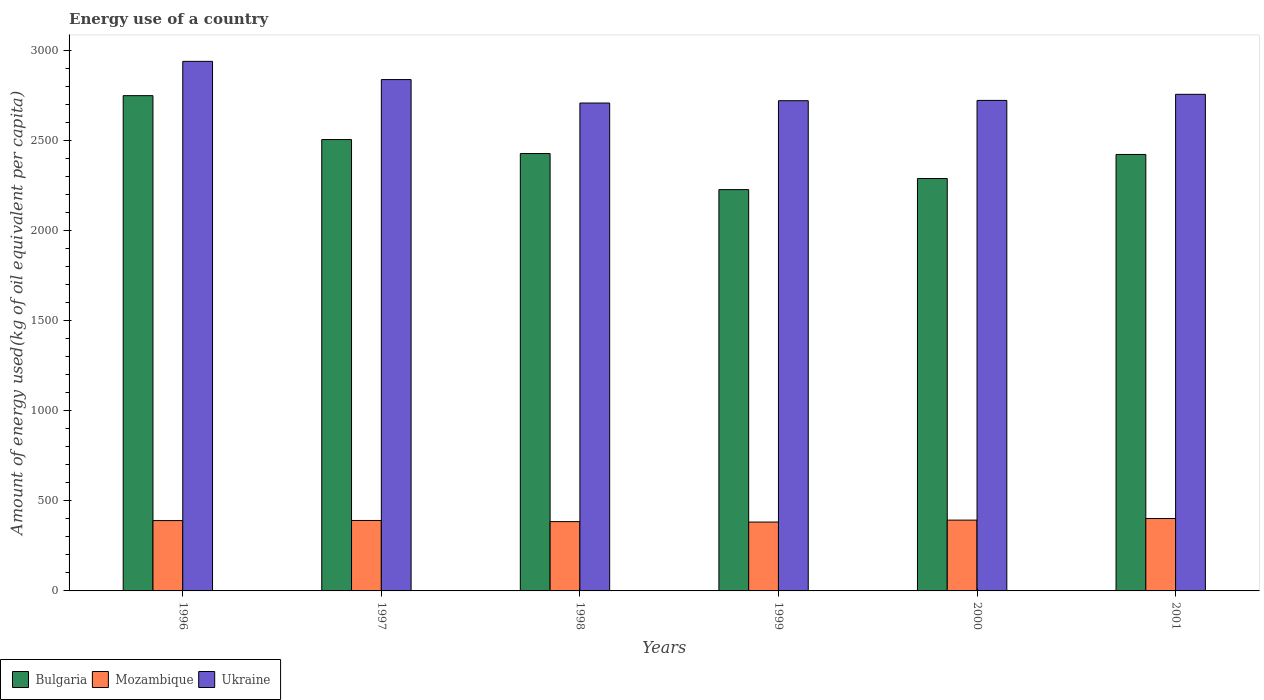How many different coloured bars are there?
Your answer should be compact. 3. How many groups of bars are there?
Offer a very short reply. 6. Are the number of bars per tick equal to the number of legend labels?
Provide a succinct answer. Yes. How many bars are there on the 6th tick from the left?
Keep it short and to the point. 3. What is the label of the 1st group of bars from the left?
Offer a terse response. 1996. In how many cases, is the number of bars for a given year not equal to the number of legend labels?
Offer a terse response. 0. What is the amount of energy used in in Bulgaria in 2000?
Keep it short and to the point. 2287.38. Across all years, what is the maximum amount of energy used in in Ukraine?
Offer a very short reply. 2937.27. Across all years, what is the minimum amount of energy used in in Mozambique?
Offer a terse response. 381.95. What is the total amount of energy used in in Ukraine in the graph?
Provide a short and direct response. 1.67e+04. What is the difference between the amount of energy used in in Ukraine in 1997 and that in 1999?
Your answer should be compact. 117.22. What is the difference between the amount of energy used in in Ukraine in 2001 and the amount of energy used in in Bulgaria in 1999?
Keep it short and to the point. 528.55. What is the average amount of energy used in in Bulgaria per year?
Keep it short and to the point. 2435.09. In the year 2001, what is the difference between the amount of energy used in in Bulgaria and amount of energy used in in Mozambique?
Your answer should be compact. 2019.27. What is the ratio of the amount of energy used in in Ukraine in 1997 to that in 1999?
Your answer should be very brief. 1.04. What is the difference between the highest and the second highest amount of energy used in in Bulgaria?
Make the answer very short. 243.43. What is the difference between the highest and the lowest amount of energy used in in Bulgaria?
Offer a very short reply. 521.09. What does the 2nd bar from the left in 2000 represents?
Ensure brevity in your answer.  Mozambique. What does the 3rd bar from the right in 1997 represents?
Offer a terse response. Bulgaria. Is it the case that in every year, the sum of the amount of energy used in in Mozambique and amount of energy used in in Bulgaria is greater than the amount of energy used in in Ukraine?
Your answer should be compact. No. How many bars are there?
Provide a short and direct response. 18. How many years are there in the graph?
Keep it short and to the point. 6. What is the difference between two consecutive major ticks on the Y-axis?
Offer a very short reply. 500. Are the values on the major ticks of Y-axis written in scientific E-notation?
Keep it short and to the point. No. Does the graph contain grids?
Your answer should be very brief. No. Where does the legend appear in the graph?
Your answer should be very brief. Bottom left. How many legend labels are there?
Provide a succinct answer. 3. How are the legend labels stacked?
Offer a very short reply. Horizontal. What is the title of the graph?
Your answer should be compact. Energy use of a country. Does "Libya" appear as one of the legend labels in the graph?
Provide a succinct answer. No. What is the label or title of the Y-axis?
Keep it short and to the point. Amount of energy used(kg of oil equivalent per capita). What is the Amount of energy used(kg of oil equivalent per capita) in Bulgaria in 1996?
Give a very brief answer. 2746.96. What is the Amount of energy used(kg of oil equivalent per capita) in Mozambique in 1996?
Make the answer very short. 390.08. What is the Amount of energy used(kg of oil equivalent per capita) in Ukraine in 1996?
Keep it short and to the point. 2937.27. What is the Amount of energy used(kg of oil equivalent per capita) in Bulgaria in 1997?
Make the answer very short. 2503.53. What is the Amount of energy used(kg of oil equivalent per capita) in Mozambique in 1997?
Provide a succinct answer. 390.69. What is the Amount of energy used(kg of oil equivalent per capita) of Ukraine in 1997?
Provide a succinct answer. 2836.21. What is the Amount of energy used(kg of oil equivalent per capita) in Bulgaria in 1998?
Give a very brief answer. 2425.95. What is the Amount of energy used(kg of oil equivalent per capita) of Mozambique in 1998?
Give a very brief answer. 384.44. What is the Amount of energy used(kg of oil equivalent per capita) of Ukraine in 1998?
Ensure brevity in your answer.  2706.14. What is the Amount of energy used(kg of oil equivalent per capita) in Bulgaria in 1999?
Give a very brief answer. 2225.87. What is the Amount of energy used(kg of oil equivalent per capita) of Mozambique in 1999?
Your answer should be compact. 381.95. What is the Amount of energy used(kg of oil equivalent per capita) of Ukraine in 1999?
Provide a succinct answer. 2718.99. What is the Amount of energy used(kg of oil equivalent per capita) in Bulgaria in 2000?
Offer a very short reply. 2287.38. What is the Amount of energy used(kg of oil equivalent per capita) in Mozambique in 2000?
Your answer should be compact. 392.71. What is the Amount of energy used(kg of oil equivalent per capita) of Ukraine in 2000?
Ensure brevity in your answer.  2720.72. What is the Amount of energy used(kg of oil equivalent per capita) in Bulgaria in 2001?
Provide a succinct answer. 2420.85. What is the Amount of energy used(kg of oil equivalent per capita) of Mozambique in 2001?
Keep it short and to the point. 401.58. What is the Amount of energy used(kg of oil equivalent per capita) of Ukraine in 2001?
Offer a very short reply. 2754.42. Across all years, what is the maximum Amount of energy used(kg of oil equivalent per capita) in Bulgaria?
Provide a short and direct response. 2746.96. Across all years, what is the maximum Amount of energy used(kg of oil equivalent per capita) of Mozambique?
Your response must be concise. 401.58. Across all years, what is the maximum Amount of energy used(kg of oil equivalent per capita) of Ukraine?
Offer a very short reply. 2937.27. Across all years, what is the minimum Amount of energy used(kg of oil equivalent per capita) in Bulgaria?
Offer a very short reply. 2225.87. Across all years, what is the minimum Amount of energy used(kg of oil equivalent per capita) in Mozambique?
Provide a short and direct response. 381.95. Across all years, what is the minimum Amount of energy used(kg of oil equivalent per capita) of Ukraine?
Give a very brief answer. 2706.14. What is the total Amount of energy used(kg of oil equivalent per capita) of Bulgaria in the graph?
Ensure brevity in your answer.  1.46e+04. What is the total Amount of energy used(kg of oil equivalent per capita) in Mozambique in the graph?
Your response must be concise. 2341.44. What is the total Amount of energy used(kg of oil equivalent per capita) in Ukraine in the graph?
Offer a terse response. 1.67e+04. What is the difference between the Amount of energy used(kg of oil equivalent per capita) in Bulgaria in 1996 and that in 1997?
Offer a very short reply. 243.43. What is the difference between the Amount of energy used(kg of oil equivalent per capita) of Mozambique in 1996 and that in 1997?
Provide a succinct answer. -0.6. What is the difference between the Amount of energy used(kg of oil equivalent per capita) in Ukraine in 1996 and that in 1997?
Your answer should be very brief. 101.06. What is the difference between the Amount of energy used(kg of oil equivalent per capita) of Bulgaria in 1996 and that in 1998?
Offer a very short reply. 321.01. What is the difference between the Amount of energy used(kg of oil equivalent per capita) of Mozambique in 1996 and that in 1998?
Make the answer very short. 5.64. What is the difference between the Amount of energy used(kg of oil equivalent per capita) of Ukraine in 1996 and that in 1998?
Offer a very short reply. 231.14. What is the difference between the Amount of energy used(kg of oil equivalent per capita) of Bulgaria in 1996 and that in 1999?
Provide a short and direct response. 521.09. What is the difference between the Amount of energy used(kg of oil equivalent per capita) in Mozambique in 1996 and that in 1999?
Your answer should be very brief. 8.14. What is the difference between the Amount of energy used(kg of oil equivalent per capita) in Ukraine in 1996 and that in 1999?
Give a very brief answer. 218.28. What is the difference between the Amount of energy used(kg of oil equivalent per capita) of Bulgaria in 1996 and that in 2000?
Your answer should be compact. 459.58. What is the difference between the Amount of energy used(kg of oil equivalent per capita) in Mozambique in 1996 and that in 2000?
Provide a short and direct response. -2.63. What is the difference between the Amount of energy used(kg of oil equivalent per capita) of Ukraine in 1996 and that in 2000?
Your answer should be compact. 216.55. What is the difference between the Amount of energy used(kg of oil equivalent per capita) in Bulgaria in 1996 and that in 2001?
Provide a succinct answer. 326.11. What is the difference between the Amount of energy used(kg of oil equivalent per capita) of Mozambique in 1996 and that in 2001?
Your response must be concise. -11.5. What is the difference between the Amount of energy used(kg of oil equivalent per capita) in Ukraine in 1996 and that in 2001?
Your answer should be compact. 182.85. What is the difference between the Amount of energy used(kg of oil equivalent per capita) of Bulgaria in 1997 and that in 1998?
Provide a short and direct response. 77.58. What is the difference between the Amount of energy used(kg of oil equivalent per capita) of Mozambique in 1997 and that in 1998?
Provide a short and direct response. 6.25. What is the difference between the Amount of energy used(kg of oil equivalent per capita) in Ukraine in 1997 and that in 1998?
Your answer should be very brief. 130.07. What is the difference between the Amount of energy used(kg of oil equivalent per capita) in Bulgaria in 1997 and that in 1999?
Offer a very short reply. 277.65. What is the difference between the Amount of energy used(kg of oil equivalent per capita) in Mozambique in 1997 and that in 1999?
Your answer should be compact. 8.74. What is the difference between the Amount of energy used(kg of oil equivalent per capita) in Ukraine in 1997 and that in 1999?
Offer a terse response. 117.22. What is the difference between the Amount of energy used(kg of oil equivalent per capita) of Bulgaria in 1997 and that in 2000?
Provide a short and direct response. 216.14. What is the difference between the Amount of energy used(kg of oil equivalent per capita) of Mozambique in 1997 and that in 2000?
Your answer should be compact. -2.03. What is the difference between the Amount of energy used(kg of oil equivalent per capita) in Ukraine in 1997 and that in 2000?
Provide a succinct answer. 115.48. What is the difference between the Amount of energy used(kg of oil equivalent per capita) in Bulgaria in 1997 and that in 2001?
Make the answer very short. 82.67. What is the difference between the Amount of energy used(kg of oil equivalent per capita) in Mozambique in 1997 and that in 2001?
Give a very brief answer. -10.9. What is the difference between the Amount of energy used(kg of oil equivalent per capita) in Ukraine in 1997 and that in 2001?
Your response must be concise. 81.78. What is the difference between the Amount of energy used(kg of oil equivalent per capita) of Bulgaria in 1998 and that in 1999?
Your response must be concise. 200.07. What is the difference between the Amount of energy used(kg of oil equivalent per capita) of Mozambique in 1998 and that in 1999?
Keep it short and to the point. 2.49. What is the difference between the Amount of energy used(kg of oil equivalent per capita) in Ukraine in 1998 and that in 1999?
Ensure brevity in your answer.  -12.86. What is the difference between the Amount of energy used(kg of oil equivalent per capita) in Bulgaria in 1998 and that in 2000?
Your response must be concise. 138.56. What is the difference between the Amount of energy used(kg of oil equivalent per capita) in Mozambique in 1998 and that in 2000?
Your response must be concise. -8.27. What is the difference between the Amount of energy used(kg of oil equivalent per capita) of Ukraine in 1998 and that in 2000?
Provide a short and direct response. -14.59. What is the difference between the Amount of energy used(kg of oil equivalent per capita) of Bulgaria in 1998 and that in 2001?
Provide a succinct answer. 5.09. What is the difference between the Amount of energy used(kg of oil equivalent per capita) of Mozambique in 1998 and that in 2001?
Ensure brevity in your answer.  -17.14. What is the difference between the Amount of energy used(kg of oil equivalent per capita) in Ukraine in 1998 and that in 2001?
Provide a succinct answer. -48.29. What is the difference between the Amount of energy used(kg of oil equivalent per capita) of Bulgaria in 1999 and that in 2000?
Ensure brevity in your answer.  -61.51. What is the difference between the Amount of energy used(kg of oil equivalent per capita) in Mozambique in 1999 and that in 2000?
Offer a very short reply. -10.76. What is the difference between the Amount of energy used(kg of oil equivalent per capita) of Ukraine in 1999 and that in 2000?
Your response must be concise. -1.73. What is the difference between the Amount of energy used(kg of oil equivalent per capita) of Bulgaria in 1999 and that in 2001?
Your response must be concise. -194.98. What is the difference between the Amount of energy used(kg of oil equivalent per capita) in Mozambique in 1999 and that in 2001?
Provide a succinct answer. -19.63. What is the difference between the Amount of energy used(kg of oil equivalent per capita) in Ukraine in 1999 and that in 2001?
Your answer should be very brief. -35.43. What is the difference between the Amount of energy used(kg of oil equivalent per capita) in Bulgaria in 2000 and that in 2001?
Provide a short and direct response. -133.47. What is the difference between the Amount of energy used(kg of oil equivalent per capita) of Mozambique in 2000 and that in 2001?
Keep it short and to the point. -8.87. What is the difference between the Amount of energy used(kg of oil equivalent per capita) of Ukraine in 2000 and that in 2001?
Ensure brevity in your answer.  -33.7. What is the difference between the Amount of energy used(kg of oil equivalent per capita) in Bulgaria in 1996 and the Amount of energy used(kg of oil equivalent per capita) in Mozambique in 1997?
Make the answer very short. 2356.28. What is the difference between the Amount of energy used(kg of oil equivalent per capita) in Bulgaria in 1996 and the Amount of energy used(kg of oil equivalent per capita) in Ukraine in 1997?
Keep it short and to the point. -89.25. What is the difference between the Amount of energy used(kg of oil equivalent per capita) of Mozambique in 1996 and the Amount of energy used(kg of oil equivalent per capita) of Ukraine in 1997?
Provide a succinct answer. -2446.13. What is the difference between the Amount of energy used(kg of oil equivalent per capita) in Bulgaria in 1996 and the Amount of energy used(kg of oil equivalent per capita) in Mozambique in 1998?
Your answer should be very brief. 2362.52. What is the difference between the Amount of energy used(kg of oil equivalent per capita) in Bulgaria in 1996 and the Amount of energy used(kg of oil equivalent per capita) in Ukraine in 1998?
Offer a very short reply. 40.82. What is the difference between the Amount of energy used(kg of oil equivalent per capita) of Mozambique in 1996 and the Amount of energy used(kg of oil equivalent per capita) of Ukraine in 1998?
Keep it short and to the point. -2316.05. What is the difference between the Amount of energy used(kg of oil equivalent per capita) in Bulgaria in 1996 and the Amount of energy used(kg of oil equivalent per capita) in Mozambique in 1999?
Offer a terse response. 2365.01. What is the difference between the Amount of energy used(kg of oil equivalent per capita) in Bulgaria in 1996 and the Amount of energy used(kg of oil equivalent per capita) in Ukraine in 1999?
Make the answer very short. 27.97. What is the difference between the Amount of energy used(kg of oil equivalent per capita) of Mozambique in 1996 and the Amount of energy used(kg of oil equivalent per capita) of Ukraine in 1999?
Make the answer very short. -2328.91. What is the difference between the Amount of energy used(kg of oil equivalent per capita) in Bulgaria in 1996 and the Amount of energy used(kg of oil equivalent per capita) in Mozambique in 2000?
Offer a terse response. 2354.25. What is the difference between the Amount of energy used(kg of oil equivalent per capita) of Bulgaria in 1996 and the Amount of energy used(kg of oil equivalent per capita) of Ukraine in 2000?
Provide a succinct answer. 26.24. What is the difference between the Amount of energy used(kg of oil equivalent per capita) of Mozambique in 1996 and the Amount of energy used(kg of oil equivalent per capita) of Ukraine in 2000?
Offer a very short reply. -2330.64. What is the difference between the Amount of energy used(kg of oil equivalent per capita) in Bulgaria in 1996 and the Amount of energy used(kg of oil equivalent per capita) in Mozambique in 2001?
Your response must be concise. 2345.38. What is the difference between the Amount of energy used(kg of oil equivalent per capita) of Bulgaria in 1996 and the Amount of energy used(kg of oil equivalent per capita) of Ukraine in 2001?
Offer a very short reply. -7.46. What is the difference between the Amount of energy used(kg of oil equivalent per capita) of Mozambique in 1996 and the Amount of energy used(kg of oil equivalent per capita) of Ukraine in 2001?
Keep it short and to the point. -2364.34. What is the difference between the Amount of energy used(kg of oil equivalent per capita) of Bulgaria in 1997 and the Amount of energy used(kg of oil equivalent per capita) of Mozambique in 1998?
Offer a terse response. 2119.09. What is the difference between the Amount of energy used(kg of oil equivalent per capita) in Bulgaria in 1997 and the Amount of energy used(kg of oil equivalent per capita) in Ukraine in 1998?
Provide a short and direct response. -202.61. What is the difference between the Amount of energy used(kg of oil equivalent per capita) in Mozambique in 1997 and the Amount of energy used(kg of oil equivalent per capita) in Ukraine in 1998?
Make the answer very short. -2315.45. What is the difference between the Amount of energy used(kg of oil equivalent per capita) of Bulgaria in 1997 and the Amount of energy used(kg of oil equivalent per capita) of Mozambique in 1999?
Your answer should be very brief. 2121.58. What is the difference between the Amount of energy used(kg of oil equivalent per capita) in Bulgaria in 1997 and the Amount of energy used(kg of oil equivalent per capita) in Ukraine in 1999?
Make the answer very short. -215.47. What is the difference between the Amount of energy used(kg of oil equivalent per capita) of Mozambique in 1997 and the Amount of energy used(kg of oil equivalent per capita) of Ukraine in 1999?
Provide a short and direct response. -2328.31. What is the difference between the Amount of energy used(kg of oil equivalent per capita) in Bulgaria in 1997 and the Amount of energy used(kg of oil equivalent per capita) in Mozambique in 2000?
Keep it short and to the point. 2110.82. What is the difference between the Amount of energy used(kg of oil equivalent per capita) of Bulgaria in 1997 and the Amount of energy used(kg of oil equivalent per capita) of Ukraine in 2000?
Give a very brief answer. -217.2. What is the difference between the Amount of energy used(kg of oil equivalent per capita) of Mozambique in 1997 and the Amount of energy used(kg of oil equivalent per capita) of Ukraine in 2000?
Offer a terse response. -2330.04. What is the difference between the Amount of energy used(kg of oil equivalent per capita) in Bulgaria in 1997 and the Amount of energy used(kg of oil equivalent per capita) in Mozambique in 2001?
Give a very brief answer. 2101.94. What is the difference between the Amount of energy used(kg of oil equivalent per capita) in Bulgaria in 1997 and the Amount of energy used(kg of oil equivalent per capita) in Ukraine in 2001?
Offer a terse response. -250.9. What is the difference between the Amount of energy used(kg of oil equivalent per capita) of Mozambique in 1997 and the Amount of energy used(kg of oil equivalent per capita) of Ukraine in 2001?
Offer a terse response. -2363.74. What is the difference between the Amount of energy used(kg of oil equivalent per capita) of Bulgaria in 1998 and the Amount of energy used(kg of oil equivalent per capita) of Mozambique in 1999?
Provide a succinct answer. 2044. What is the difference between the Amount of energy used(kg of oil equivalent per capita) in Bulgaria in 1998 and the Amount of energy used(kg of oil equivalent per capita) in Ukraine in 1999?
Provide a succinct answer. -293.05. What is the difference between the Amount of energy used(kg of oil equivalent per capita) of Mozambique in 1998 and the Amount of energy used(kg of oil equivalent per capita) of Ukraine in 1999?
Give a very brief answer. -2334.55. What is the difference between the Amount of energy used(kg of oil equivalent per capita) in Bulgaria in 1998 and the Amount of energy used(kg of oil equivalent per capita) in Mozambique in 2000?
Offer a very short reply. 2033.24. What is the difference between the Amount of energy used(kg of oil equivalent per capita) of Bulgaria in 1998 and the Amount of energy used(kg of oil equivalent per capita) of Ukraine in 2000?
Your answer should be compact. -294.78. What is the difference between the Amount of energy used(kg of oil equivalent per capita) of Mozambique in 1998 and the Amount of energy used(kg of oil equivalent per capita) of Ukraine in 2000?
Make the answer very short. -2336.29. What is the difference between the Amount of energy used(kg of oil equivalent per capita) in Bulgaria in 1998 and the Amount of energy used(kg of oil equivalent per capita) in Mozambique in 2001?
Give a very brief answer. 2024.36. What is the difference between the Amount of energy used(kg of oil equivalent per capita) of Bulgaria in 1998 and the Amount of energy used(kg of oil equivalent per capita) of Ukraine in 2001?
Provide a succinct answer. -328.48. What is the difference between the Amount of energy used(kg of oil equivalent per capita) in Mozambique in 1998 and the Amount of energy used(kg of oil equivalent per capita) in Ukraine in 2001?
Your answer should be compact. -2369.99. What is the difference between the Amount of energy used(kg of oil equivalent per capita) in Bulgaria in 1999 and the Amount of energy used(kg of oil equivalent per capita) in Mozambique in 2000?
Offer a very short reply. 1833.16. What is the difference between the Amount of energy used(kg of oil equivalent per capita) of Bulgaria in 1999 and the Amount of energy used(kg of oil equivalent per capita) of Ukraine in 2000?
Offer a very short reply. -494.85. What is the difference between the Amount of energy used(kg of oil equivalent per capita) of Mozambique in 1999 and the Amount of energy used(kg of oil equivalent per capita) of Ukraine in 2000?
Offer a terse response. -2338.78. What is the difference between the Amount of energy used(kg of oil equivalent per capita) of Bulgaria in 1999 and the Amount of energy used(kg of oil equivalent per capita) of Mozambique in 2001?
Ensure brevity in your answer.  1824.29. What is the difference between the Amount of energy used(kg of oil equivalent per capita) of Bulgaria in 1999 and the Amount of energy used(kg of oil equivalent per capita) of Ukraine in 2001?
Ensure brevity in your answer.  -528.55. What is the difference between the Amount of energy used(kg of oil equivalent per capita) in Mozambique in 1999 and the Amount of energy used(kg of oil equivalent per capita) in Ukraine in 2001?
Keep it short and to the point. -2372.48. What is the difference between the Amount of energy used(kg of oil equivalent per capita) of Bulgaria in 2000 and the Amount of energy used(kg of oil equivalent per capita) of Mozambique in 2001?
Give a very brief answer. 1885.8. What is the difference between the Amount of energy used(kg of oil equivalent per capita) of Bulgaria in 2000 and the Amount of energy used(kg of oil equivalent per capita) of Ukraine in 2001?
Your answer should be compact. -467.04. What is the difference between the Amount of energy used(kg of oil equivalent per capita) of Mozambique in 2000 and the Amount of energy used(kg of oil equivalent per capita) of Ukraine in 2001?
Your answer should be very brief. -2361.71. What is the average Amount of energy used(kg of oil equivalent per capita) of Bulgaria per year?
Offer a terse response. 2435.09. What is the average Amount of energy used(kg of oil equivalent per capita) of Mozambique per year?
Provide a short and direct response. 390.24. What is the average Amount of energy used(kg of oil equivalent per capita) in Ukraine per year?
Give a very brief answer. 2778.96. In the year 1996, what is the difference between the Amount of energy used(kg of oil equivalent per capita) in Bulgaria and Amount of energy used(kg of oil equivalent per capita) in Mozambique?
Keep it short and to the point. 2356.88. In the year 1996, what is the difference between the Amount of energy used(kg of oil equivalent per capita) of Bulgaria and Amount of energy used(kg of oil equivalent per capita) of Ukraine?
Give a very brief answer. -190.31. In the year 1996, what is the difference between the Amount of energy used(kg of oil equivalent per capita) of Mozambique and Amount of energy used(kg of oil equivalent per capita) of Ukraine?
Your response must be concise. -2547.19. In the year 1997, what is the difference between the Amount of energy used(kg of oil equivalent per capita) in Bulgaria and Amount of energy used(kg of oil equivalent per capita) in Mozambique?
Provide a succinct answer. 2112.84. In the year 1997, what is the difference between the Amount of energy used(kg of oil equivalent per capita) in Bulgaria and Amount of energy used(kg of oil equivalent per capita) in Ukraine?
Give a very brief answer. -332.68. In the year 1997, what is the difference between the Amount of energy used(kg of oil equivalent per capita) of Mozambique and Amount of energy used(kg of oil equivalent per capita) of Ukraine?
Ensure brevity in your answer.  -2445.52. In the year 1998, what is the difference between the Amount of energy used(kg of oil equivalent per capita) of Bulgaria and Amount of energy used(kg of oil equivalent per capita) of Mozambique?
Offer a terse response. 2041.51. In the year 1998, what is the difference between the Amount of energy used(kg of oil equivalent per capita) in Bulgaria and Amount of energy used(kg of oil equivalent per capita) in Ukraine?
Offer a very short reply. -280.19. In the year 1998, what is the difference between the Amount of energy used(kg of oil equivalent per capita) in Mozambique and Amount of energy used(kg of oil equivalent per capita) in Ukraine?
Keep it short and to the point. -2321.7. In the year 1999, what is the difference between the Amount of energy used(kg of oil equivalent per capita) of Bulgaria and Amount of energy used(kg of oil equivalent per capita) of Mozambique?
Ensure brevity in your answer.  1843.93. In the year 1999, what is the difference between the Amount of energy used(kg of oil equivalent per capita) in Bulgaria and Amount of energy used(kg of oil equivalent per capita) in Ukraine?
Ensure brevity in your answer.  -493.12. In the year 1999, what is the difference between the Amount of energy used(kg of oil equivalent per capita) in Mozambique and Amount of energy used(kg of oil equivalent per capita) in Ukraine?
Ensure brevity in your answer.  -2337.04. In the year 2000, what is the difference between the Amount of energy used(kg of oil equivalent per capita) of Bulgaria and Amount of energy used(kg of oil equivalent per capita) of Mozambique?
Give a very brief answer. 1894.67. In the year 2000, what is the difference between the Amount of energy used(kg of oil equivalent per capita) in Bulgaria and Amount of energy used(kg of oil equivalent per capita) in Ukraine?
Give a very brief answer. -433.34. In the year 2000, what is the difference between the Amount of energy used(kg of oil equivalent per capita) of Mozambique and Amount of energy used(kg of oil equivalent per capita) of Ukraine?
Give a very brief answer. -2328.01. In the year 2001, what is the difference between the Amount of energy used(kg of oil equivalent per capita) of Bulgaria and Amount of energy used(kg of oil equivalent per capita) of Mozambique?
Offer a terse response. 2019.27. In the year 2001, what is the difference between the Amount of energy used(kg of oil equivalent per capita) in Bulgaria and Amount of energy used(kg of oil equivalent per capita) in Ukraine?
Provide a short and direct response. -333.57. In the year 2001, what is the difference between the Amount of energy used(kg of oil equivalent per capita) in Mozambique and Amount of energy used(kg of oil equivalent per capita) in Ukraine?
Your answer should be compact. -2352.84. What is the ratio of the Amount of energy used(kg of oil equivalent per capita) in Bulgaria in 1996 to that in 1997?
Make the answer very short. 1.1. What is the ratio of the Amount of energy used(kg of oil equivalent per capita) in Mozambique in 1996 to that in 1997?
Your response must be concise. 1. What is the ratio of the Amount of energy used(kg of oil equivalent per capita) in Ukraine in 1996 to that in 1997?
Provide a succinct answer. 1.04. What is the ratio of the Amount of energy used(kg of oil equivalent per capita) in Bulgaria in 1996 to that in 1998?
Your response must be concise. 1.13. What is the ratio of the Amount of energy used(kg of oil equivalent per capita) in Mozambique in 1996 to that in 1998?
Make the answer very short. 1.01. What is the ratio of the Amount of energy used(kg of oil equivalent per capita) in Ukraine in 1996 to that in 1998?
Your answer should be very brief. 1.09. What is the ratio of the Amount of energy used(kg of oil equivalent per capita) in Bulgaria in 1996 to that in 1999?
Ensure brevity in your answer.  1.23. What is the ratio of the Amount of energy used(kg of oil equivalent per capita) in Mozambique in 1996 to that in 1999?
Your answer should be compact. 1.02. What is the ratio of the Amount of energy used(kg of oil equivalent per capita) of Ukraine in 1996 to that in 1999?
Your answer should be compact. 1.08. What is the ratio of the Amount of energy used(kg of oil equivalent per capita) of Bulgaria in 1996 to that in 2000?
Ensure brevity in your answer.  1.2. What is the ratio of the Amount of energy used(kg of oil equivalent per capita) of Mozambique in 1996 to that in 2000?
Ensure brevity in your answer.  0.99. What is the ratio of the Amount of energy used(kg of oil equivalent per capita) in Ukraine in 1996 to that in 2000?
Provide a short and direct response. 1.08. What is the ratio of the Amount of energy used(kg of oil equivalent per capita) in Bulgaria in 1996 to that in 2001?
Keep it short and to the point. 1.13. What is the ratio of the Amount of energy used(kg of oil equivalent per capita) of Mozambique in 1996 to that in 2001?
Your answer should be compact. 0.97. What is the ratio of the Amount of energy used(kg of oil equivalent per capita) in Ukraine in 1996 to that in 2001?
Your answer should be very brief. 1.07. What is the ratio of the Amount of energy used(kg of oil equivalent per capita) in Bulgaria in 1997 to that in 1998?
Provide a succinct answer. 1.03. What is the ratio of the Amount of energy used(kg of oil equivalent per capita) in Mozambique in 1997 to that in 1998?
Offer a very short reply. 1.02. What is the ratio of the Amount of energy used(kg of oil equivalent per capita) in Ukraine in 1997 to that in 1998?
Offer a terse response. 1.05. What is the ratio of the Amount of energy used(kg of oil equivalent per capita) of Bulgaria in 1997 to that in 1999?
Ensure brevity in your answer.  1.12. What is the ratio of the Amount of energy used(kg of oil equivalent per capita) of Mozambique in 1997 to that in 1999?
Offer a terse response. 1.02. What is the ratio of the Amount of energy used(kg of oil equivalent per capita) in Ukraine in 1997 to that in 1999?
Provide a succinct answer. 1.04. What is the ratio of the Amount of energy used(kg of oil equivalent per capita) of Bulgaria in 1997 to that in 2000?
Offer a very short reply. 1.09. What is the ratio of the Amount of energy used(kg of oil equivalent per capita) in Mozambique in 1997 to that in 2000?
Provide a succinct answer. 0.99. What is the ratio of the Amount of energy used(kg of oil equivalent per capita) in Ukraine in 1997 to that in 2000?
Provide a short and direct response. 1.04. What is the ratio of the Amount of energy used(kg of oil equivalent per capita) in Bulgaria in 1997 to that in 2001?
Your answer should be compact. 1.03. What is the ratio of the Amount of energy used(kg of oil equivalent per capita) in Mozambique in 1997 to that in 2001?
Your answer should be very brief. 0.97. What is the ratio of the Amount of energy used(kg of oil equivalent per capita) of Ukraine in 1997 to that in 2001?
Your answer should be compact. 1.03. What is the ratio of the Amount of energy used(kg of oil equivalent per capita) of Bulgaria in 1998 to that in 1999?
Your answer should be very brief. 1.09. What is the ratio of the Amount of energy used(kg of oil equivalent per capita) in Ukraine in 1998 to that in 1999?
Your answer should be compact. 1. What is the ratio of the Amount of energy used(kg of oil equivalent per capita) in Bulgaria in 1998 to that in 2000?
Keep it short and to the point. 1.06. What is the ratio of the Amount of energy used(kg of oil equivalent per capita) of Mozambique in 1998 to that in 2000?
Provide a short and direct response. 0.98. What is the ratio of the Amount of energy used(kg of oil equivalent per capita) of Ukraine in 1998 to that in 2000?
Provide a succinct answer. 0.99. What is the ratio of the Amount of energy used(kg of oil equivalent per capita) of Mozambique in 1998 to that in 2001?
Provide a short and direct response. 0.96. What is the ratio of the Amount of energy used(kg of oil equivalent per capita) of Ukraine in 1998 to that in 2001?
Provide a succinct answer. 0.98. What is the ratio of the Amount of energy used(kg of oil equivalent per capita) in Bulgaria in 1999 to that in 2000?
Ensure brevity in your answer.  0.97. What is the ratio of the Amount of energy used(kg of oil equivalent per capita) of Mozambique in 1999 to that in 2000?
Give a very brief answer. 0.97. What is the ratio of the Amount of energy used(kg of oil equivalent per capita) of Ukraine in 1999 to that in 2000?
Ensure brevity in your answer.  1. What is the ratio of the Amount of energy used(kg of oil equivalent per capita) in Bulgaria in 1999 to that in 2001?
Your response must be concise. 0.92. What is the ratio of the Amount of energy used(kg of oil equivalent per capita) in Mozambique in 1999 to that in 2001?
Provide a succinct answer. 0.95. What is the ratio of the Amount of energy used(kg of oil equivalent per capita) of Ukraine in 1999 to that in 2001?
Keep it short and to the point. 0.99. What is the ratio of the Amount of energy used(kg of oil equivalent per capita) of Bulgaria in 2000 to that in 2001?
Give a very brief answer. 0.94. What is the ratio of the Amount of energy used(kg of oil equivalent per capita) of Mozambique in 2000 to that in 2001?
Offer a terse response. 0.98. What is the ratio of the Amount of energy used(kg of oil equivalent per capita) in Ukraine in 2000 to that in 2001?
Make the answer very short. 0.99. What is the difference between the highest and the second highest Amount of energy used(kg of oil equivalent per capita) of Bulgaria?
Provide a succinct answer. 243.43. What is the difference between the highest and the second highest Amount of energy used(kg of oil equivalent per capita) of Mozambique?
Provide a succinct answer. 8.87. What is the difference between the highest and the second highest Amount of energy used(kg of oil equivalent per capita) of Ukraine?
Give a very brief answer. 101.06. What is the difference between the highest and the lowest Amount of energy used(kg of oil equivalent per capita) in Bulgaria?
Provide a short and direct response. 521.09. What is the difference between the highest and the lowest Amount of energy used(kg of oil equivalent per capita) in Mozambique?
Make the answer very short. 19.63. What is the difference between the highest and the lowest Amount of energy used(kg of oil equivalent per capita) in Ukraine?
Give a very brief answer. 231.14. 